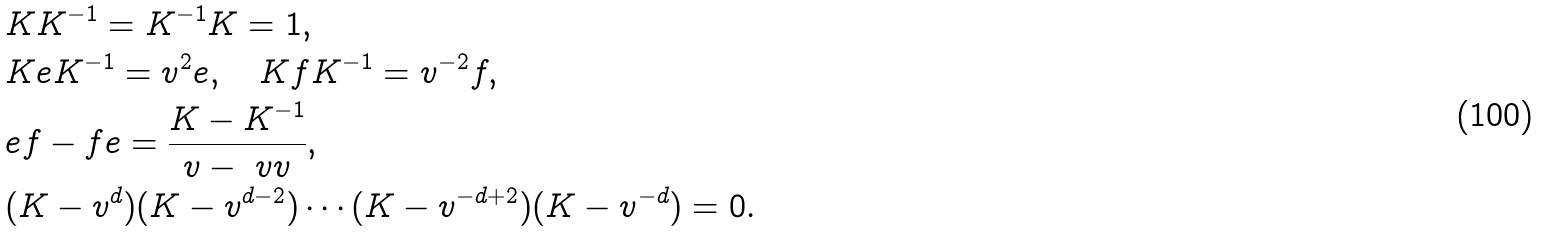Convert formula to latex. <formula><loc_0><loc_0><loc_500><loc_500>& K K ^ { - 1 } = K ^ { - 1 } K = 1 , \\ & K e K ^ { - 1 } = v ^ { 2 } e , \quad K f K ^ { - 1 } = v ^ { - 2 } f , \\ & e f - f e = \frac { K - K ^ { - 1 } } { v - \ v v } , \\ & ( K - v ^ { d } ) ( K - v ^ { d - 2 } ) \cdots ( K - v ^ { - d + 2 } ) ( K - v ^ { - d } ) = 0 .</formula> 